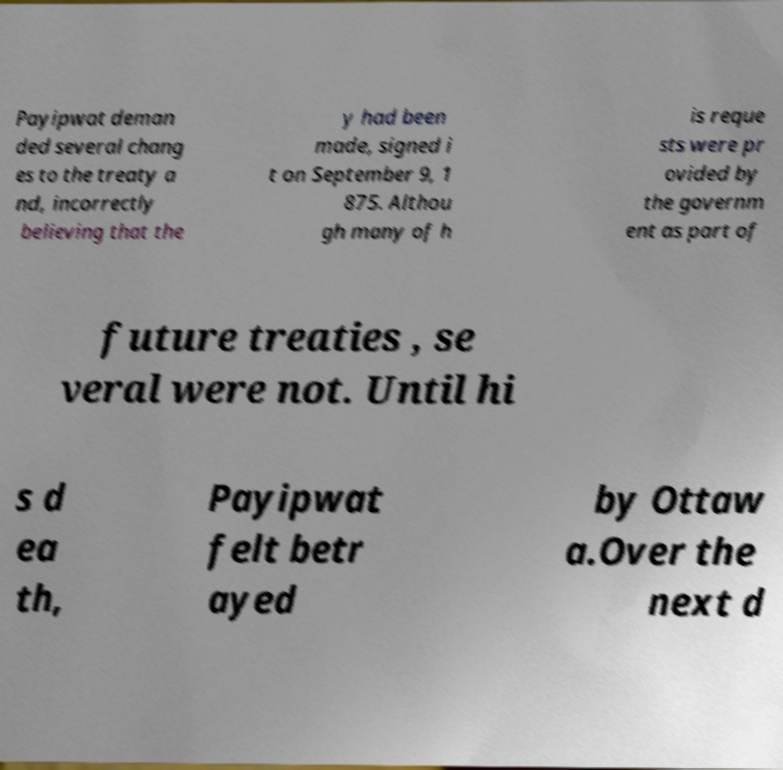Can you read and provide the text displayed in the image?This photo seems to have some interesting text. Can you extract and type it out for me? Payipwat deman ded several chang es to the treaty a nd, incorrectly believing that the y had been made, signed i t on September 9, 1 875. Althou gh many of h is reque sts were pr ovided by the governm ent as part of future treaties , se veral were not. Until hi s d ea th, Payipwat felt betr ayed by Ottaw a.Over the next d 